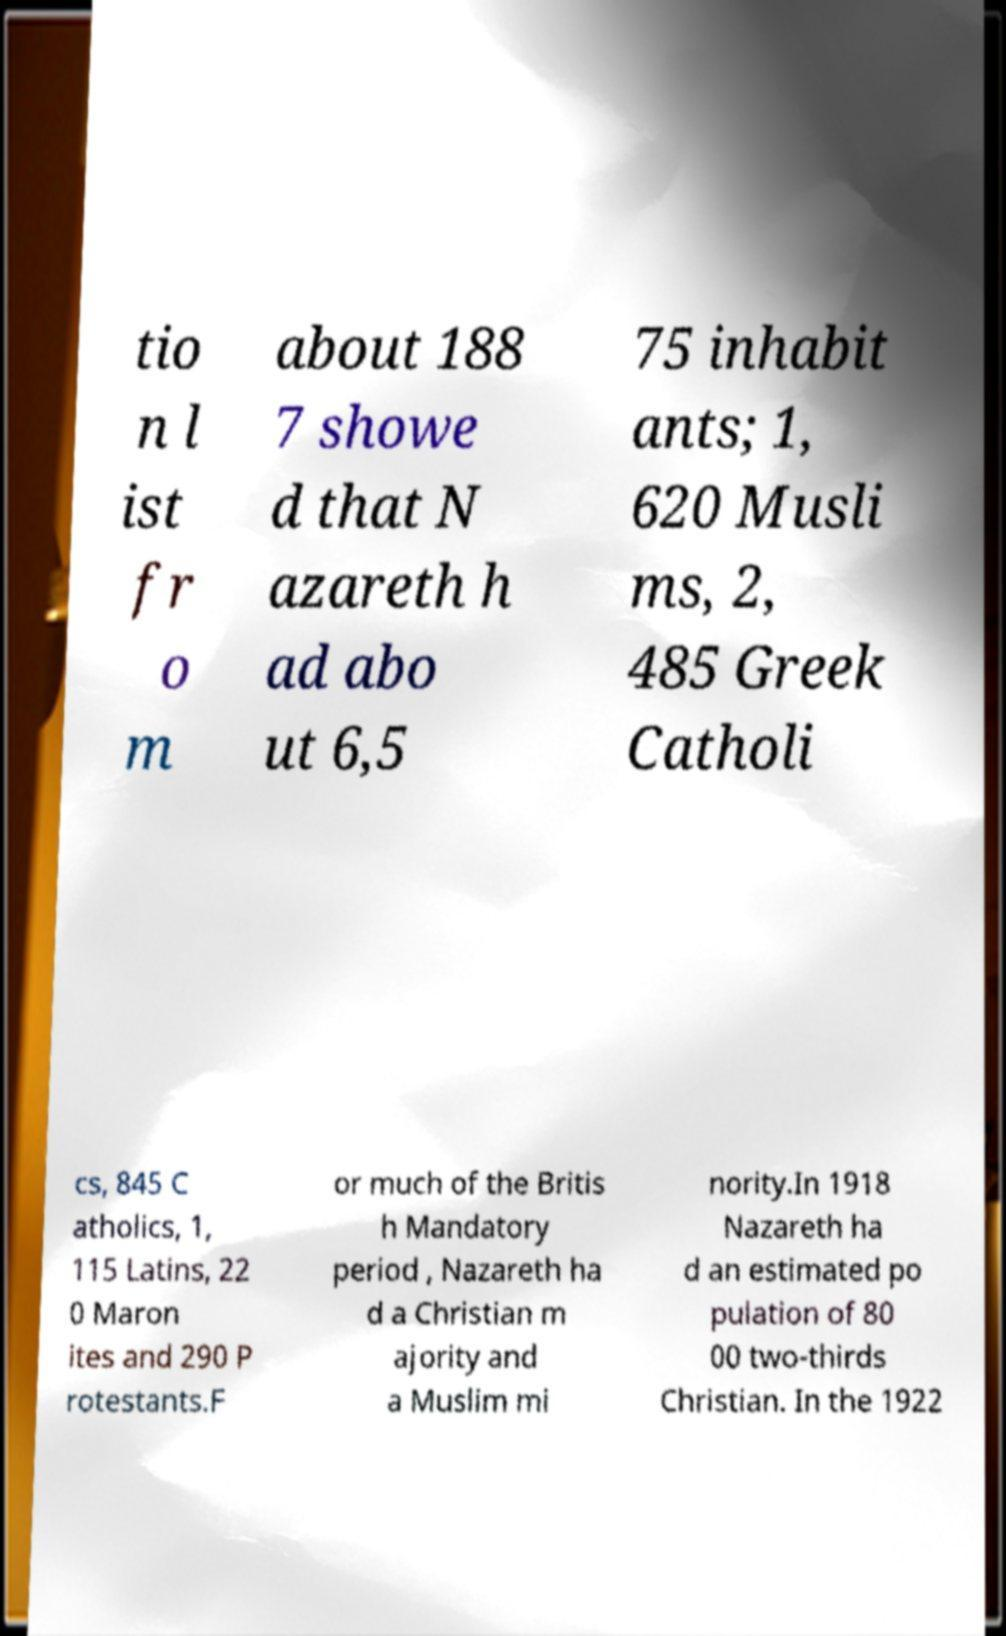Please read and relay the text visible in this image. What does it say? tio n l ist fr o m about 188 7 showe d that N azareth h ad abo ut 6,5 75 inhabit ants; 1, 620 Musli ms, 2, 485 Greek Catholi cs, 845 C atholics, 1, 115 Latins, 22 0 Maron ites and 290 P rotestants.F or much of the Britis h Mandatory period , Nazareth ha d a Christian m ajority and a Muslim mi nority.In 1918 Nazareth ha d an estimated po pulation of 80 00 two-thirds Christian. In the 1922 